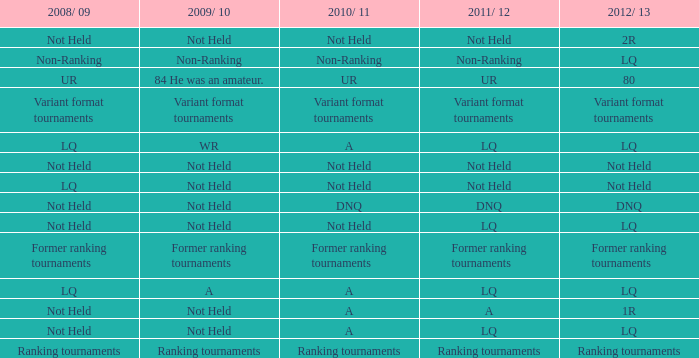When the 2008/ 09 has non-ranking what is the 2009/ 10? Non-Ranking. 